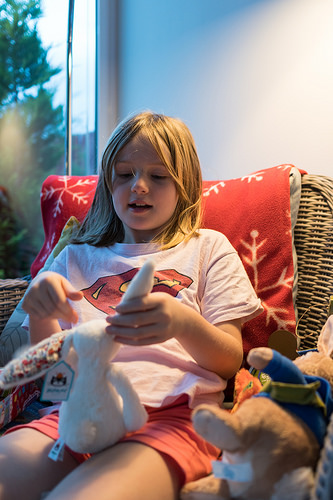<image>
Is the rabbit on the girl? No. The rabbit is not positioned on the girl. They may be near each other, but the rabbit is not supported by or resting on top of the girl. 